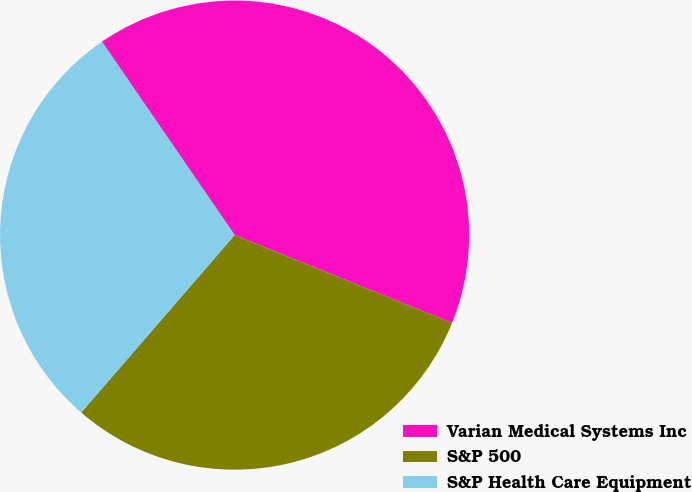<chart> <loc_0><loc_0><loc_500><loc_500><pie_chart><fcel>Varian Medical Systems Inc<fcel>S&P 500<fcel>S&P Health Care Equipment<nl><fcel>40.69%<fcel>30.24%<fcel>29.08%<nl></chart> 